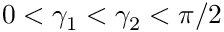<formula> <loc_0><loc_0><loc_500><loc_500>0 < \gamma _ { 1 } < \gamma _ { 2 } < \pi / 2</formula> 